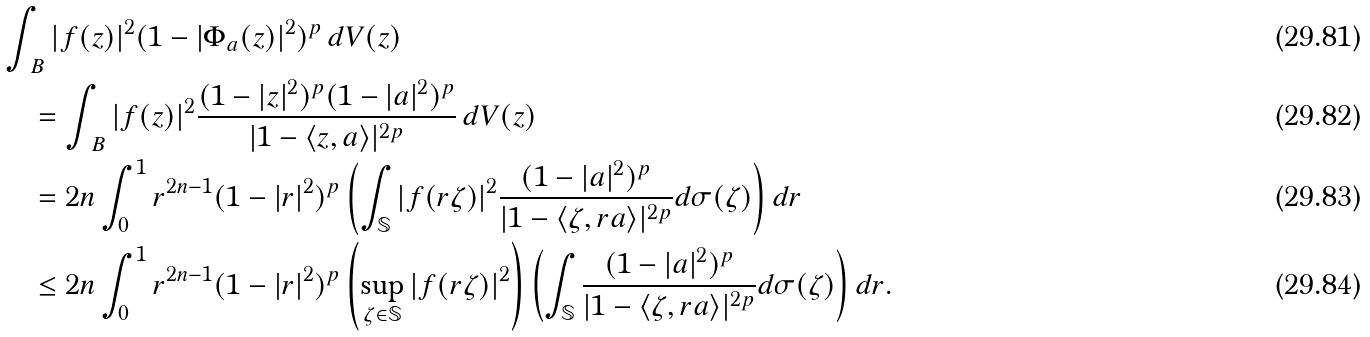<formula> <loc_0><loc_0><loc_500><loc_500>& \int _ { \ B } | f ( z ) | ^ { 2 } ( 1 - | \Phi _ { a } ( z ) | ^ { 2 } ) ^ { p } \, d V ( z ) \\ & \quad = \int _ { \ B } | f ( z ) | ^ { 2 } \frac { ( 1 - | z | ^ { 2 } ) ^ { p } ( 1 - | a | ^ { 2 } ) ^ { p } } { | 1 - \langle z , a \rangle | ^ { 2 p } } \, d V ( z ) \\ & \quad = 2 n \int _ { 0 } ^ { 1 } r ^ { 2 n - 1 } ( 1 - | r | ^ { 2 } ) ^ { p } \left ( \int _ { \mathbb { S } } | f ( r \zeta ) | ^ { 2 } \frac { ( 1 - | a | ^ { 2 } ) ^ { p } } { | 1 - \langle \zeta , r a \rangle | ^ { 2 p } } d \sigma ( \zeta ) \right ) d r \\ & \quad \leq 2 n \int _ { 0 } ^ { 1 } r ^ { 2 n - 1 } ( 1 - | r | ^ { 2 } ) ^ { p } \left ( \sup _ { \zeta \in \mathbb { S } } | f ( r \zeta ) | ^ { 2 } \right ) \left ( \int _ { \mathbb { S } } \frac { ( 1 - | a | ^ { 2 } ) ^ { p } } { | 1 - \langle \zeta , r a \rangle | ^ { 2 p } } d \sigma ( \zeta ) \right ) d r .</formula> 